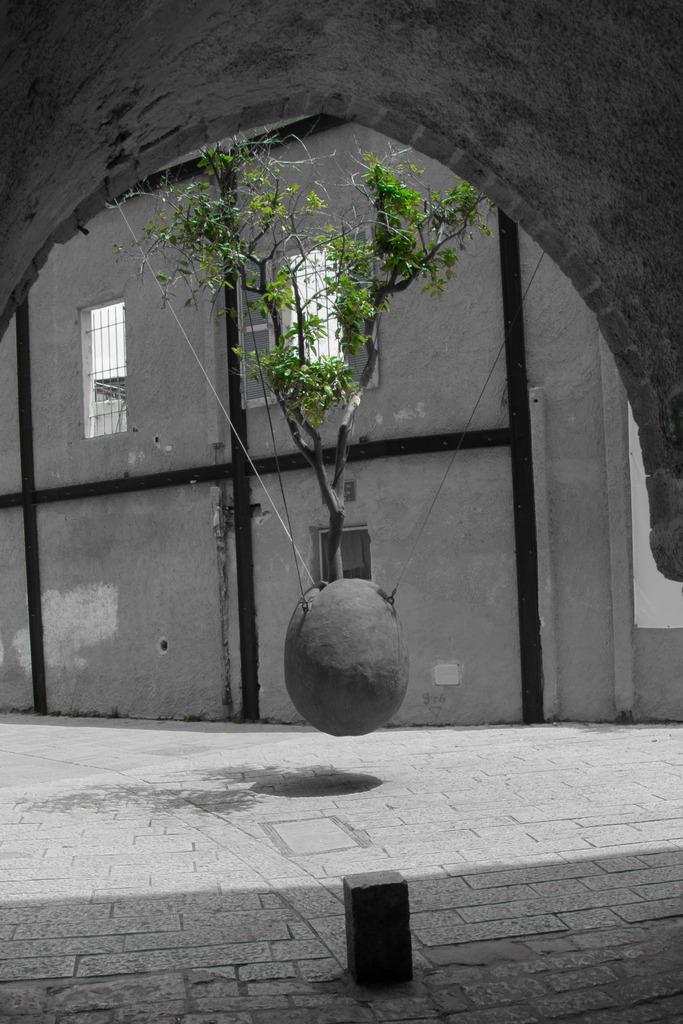Could you give a brief overview of what you see in this image? In this image I can see the floor, a grey colored object and a tree which is green and black in color. In the background I can see the wall and few windows through which I can see the sky. 